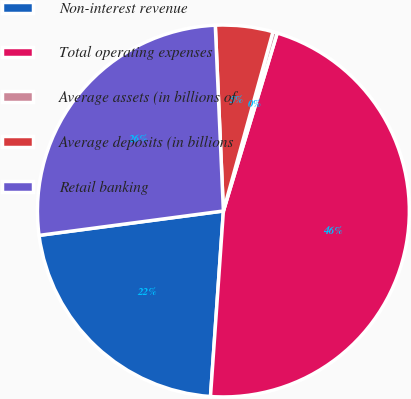Convert chart to OTSL. <chart><loc_0><loc_0><loc_500><loc_500><pie_chart><fcel>Non-interest revenue<fcel>Total operating expenses<fcel>Average assets (in billions of<fcel>Average deposits (in billions<fcel>Retail banking<nl><fcel>21.8%<fcel>46.43%<fcel>0.38%<fcel>4.99%<fcel>26.4%<nl></chart> 